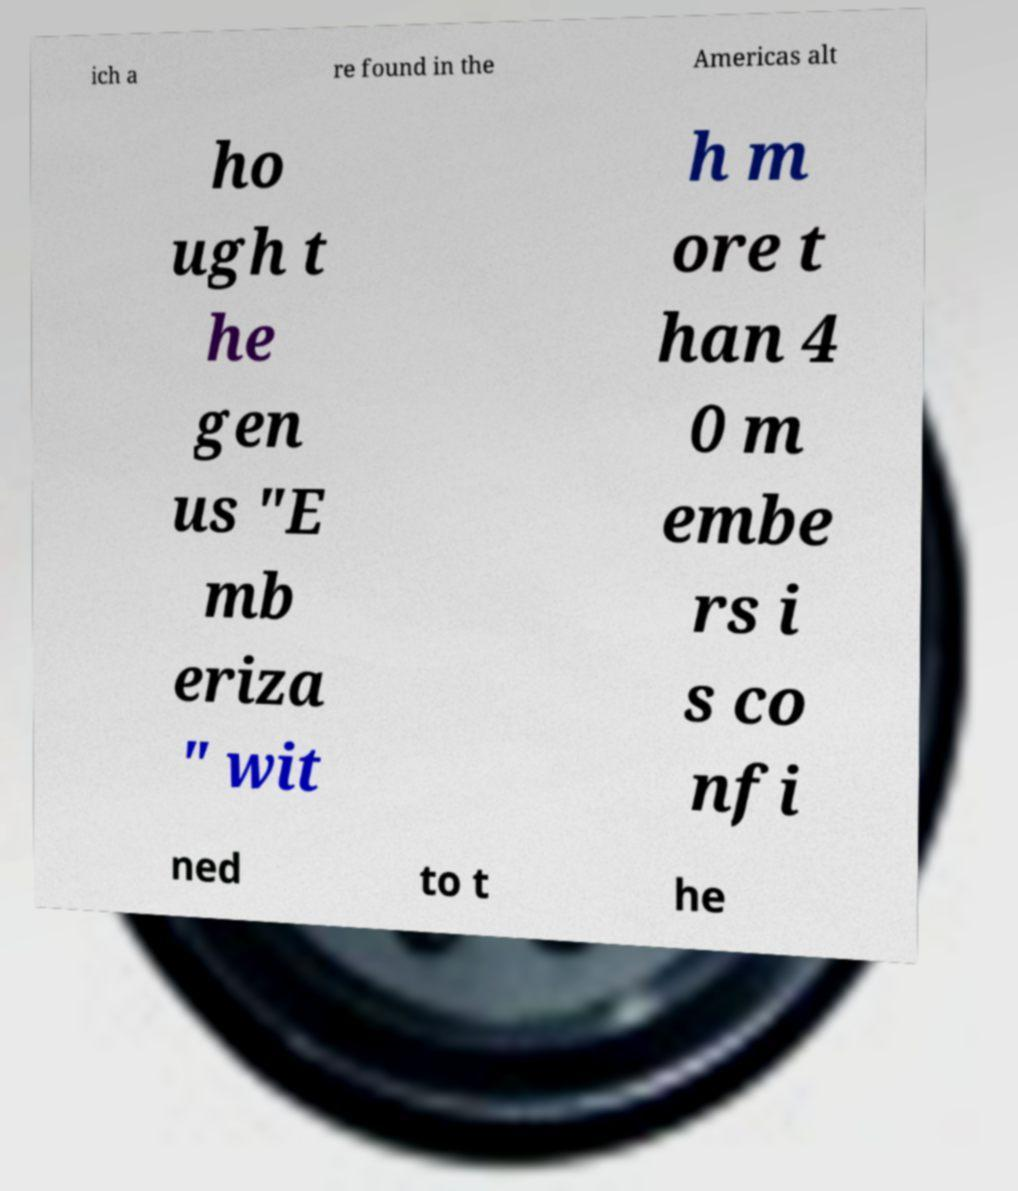Please read and relay the text visible in this image. What does it say? ich a re found in the Americas alt ho ugh t he gen us "E mb eriza " wit h m ore t han 4 0 m embe rs i s co nfi ned to t he 